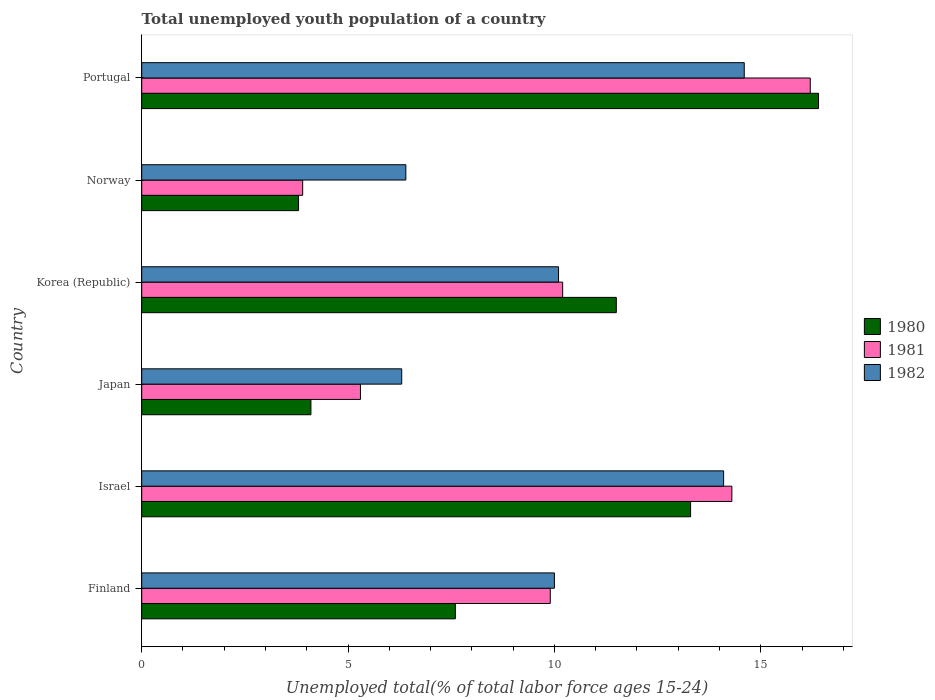How many different coloured bars are there?
Provide a succinct answer. 3. Are the number of bars per tick equal to the number of legend labels?
Your answer should be very brief. Yes. Are the number of bars on each tick of the Y-axis equal?
Keep it short and to the point. Yes. How many bars are there on the 2nd tick from the bottom?
Your answer should be compact. 3. What is the percentage of total unemployed youth population of a country in 1981 in Norway?
Your answer should be compact. 3.9. Across all countries, what is the maximum percentage of total unemployed youth population of a country in 1981?
Keep it short and to the point. 16.2. Across all countries, what is the minimum percentage of total unemployed youth population of a country in 1980?
Ensure brevity in your answer.  3.8. In which country was the percentage of total unemployed youth population of a country in 1980 maximum?
Provide a succinct answer. Portugal. In which country was the percentage of total unemployed youth population of a country in 1982 minimum?
Ensure brevity in your answer.  Japan. What is the total percentage of total unemployed youth population of a country in 1980 in the graph?
Give a very brief answer. 56.7. What is the difference between the percentage of total unemployed youth population of a country in 1980 in Finland and that in Japan?
Provide a short and direct response. 3.5. What is the difference between the percentage of total unemployed youth population of a country in 1982 in Portugal and the percentage of total unemployed youth population of a country in 1981 in Korea (Republic)?
Ensure brevity in your answer.  4.4. What is the average percentage of total unemployed youth population of a country in 1982 per country?
Provide a succinct answer. 10.25. What is the difference between the percentage of total unemployed youth population of a country in 1980 and percentage of total unemployed youth population of a country in 1982 in Portugal?
Offer a terse response. 1.8. What is the ratio of the percentage of total unemployed youth population of a country in 1982 in Israel to that in Norway?
Your answer should be compact. 2.2. What is the difference between the highest and the lowest percentage of total unemployed youth population of a country in 1981?
Offer a terse response. 12.3. In how many countries, is the percentage of total unemployed youth population of a country in 1982 greater than the average percentage of total unemployed youth population of a country in 1982 taken over all countries?
Offer a terse response. 2. What does the 1st bar from the top in Portugal represents?
Offer a very short reply. 1982. Is it the case that in every country, the sum of the percentage of total unemployed youth population of a country in 1980 and percentage of total unemployed youth population of a country in 1981 is greater than the percentage of total unemployed youth population of a country in 1982?
Ensure brevity in your answer.  Yes. How many bars are there?
Provide a succinct answer. 18. How many countries are there in the graph?
Your response must be concise. 6. Are the values on the major ticks of X-axis written in scientific E-notation?
Provide a short and direct response. No. Does the graph contain any zero values?
Offer a very short reply. No. Where does the legend appear in the graph?
Give a very brief answer. Center right. What is the title of the graph?
Provide a short and direct response. Total unemployed youth population of a country. Does "2013" appear as one of the legend labels in the graph?
Your answer should be compact. No. What is the label or title of the X-axis?
Keep it short and to the point. Unemployed total(% of total labor force ages 15-24). What is the label or title of the Y-axis?
Your answer should be very brief. Country. What is the Unemployed total(% of total labor force ages 15-24) in 1980 in Finland?
Ensure brevity in your answer.  7.6. What is the Unemployed total(% of total labor force ages 15-24) in 1981 in Finland?
Your answer should be very brief. 9.9. What is the Unemployed total(% of total labor force ages 15-24) of 1982 in Finland?
Ensure brevity in your answer.  10. What is the Unemployed total(% of total labor force ages 15-24) of 1980 in Israel?
Your response must be concise. 13.3. What is the Unemployed total(% of total labor force ages 15-24) of 1981 in Israel?
Your response must be concise. 14.3. What is the Unemployed total(% of total labor force ages 15-24) of 1982 in Israel?
Provide a short and direct response. 14.1. What is the Unemployed total(% of total labor force ages 15-24) in 1980 in Japan?
Ensure brevity in your answer.  4.1. What is the Unemployed total(% of total labor force ages 15-24) in 1981 in Japan?
Keep it short and to the point. 5.3. What is the Unemployed total(% of total labor force ages 15-24) in 1982 in Japan?
Make the answer very short. 6.3. What is the Unemployed total(% of total labor force ages 15-24) in 1981 in Korea (Republic)?
Keep it short and to the point. 10.2. What is the Unemployed total(% of total labor force ages 15-24) of 1982 in Korea (Republic)?
Offer a very short reply. 10.1. What is the Unemployed total(% of total labor force ages 15-24) of 1980 in Norway?
Offer a very short reply. 3.8. What is the Unemployed total(% of total labor force ages 15-24) in 1981 in Norway?
Provide a short and direct response. 3.9. What is the Unemployed total(% of total labor force ages 15-24) of 1982 in Norway?
Your answer should be compact. 6.4. What is the Unemployed total(% of total labor force ages 15-24) in 1980 in Portugal?
Keep it short and to the point. 16.4. What is the Unemployed total(% of total labor force ages 15-24) in 1981 in Portugal?
Keep it short and to the point. 16.2. What is the Unemployed total(% of total labor force ages 15-24) in 1982 in Portugal?
Offer a terse response. 14.6. Across all countries, what is the maximum Unemployed total(% of total labor force ages 15-24) in 1980?
Keep it short and to the point. 16.4. Across all countries, what is the maximum Unemployed total(% of total labor force ages 15-24) of 1981?
Your answer should be compact. 16.2. Across all countries, what is the maximum Unemployed total(% of total labor force ages 15-24) of 1982?
Keep it short and to the point. 14.6. Across all countries, what is the minimum Unemployed total(% of total labor force ages 15-24) in 1980?
Offer a very short reply. 3.8. Across all countries, what is the minimum Unemployed total(% of total labor force ages 15-24) of 1981?
Your answer should be compact. 3.9. Across all countries, what is the minimum Unemployed total(% of total labor force ages 15-24) of 1982?
Provide a succinct answer. 6.3. What is the total Unemployed total(% of total labor force ages 15-24) in 1980 in the graph?
Provide a succinct answer. 56.7. What is the total Unemployed total(% of total labor force ages 15-24) of 1981 in the graph?
Give a very brief answer. 59.8. What is the total Unemployed total(% of total labor force ages 15-24) of 1982 in the graph?
Make the answer very short. 61.5. What is the difference between the Unemployed total(% of total labor force ages 15-24) in 1981 in Finland and that in Israel?
Ensure brevity in your answer.  -4.4. What is the difference between the Unemployed total(% of total labor force ages 15-24) in 1982 in Finland and that in Israel?
Provide a succinct answer. -4.1. What is the difference between the Unemployed total(% of total labor force ages 15-24) in 1980 in Finland and that in Korea (Republic)?
Give a very brief answer. -3.9. What is the difference between the Unemployed total(% of total labor force ages 15-24) in 1981 in Finland and that in Korea (Republic)?
Give a very brief answer. -0.3. What is the difference between the Unemployed total(% of total labor force ages 15-24) of 1982 in Finland and that in Korea (Republic)?
Your answer should be compact. -0.1. What is the difference between the Unemployed total(% of total labor force ages 15-24) of 1980 in Finland and that in Portugal?
Ensure brevity in your answer.  -8.8. What is the difference between the Unemployed total(% of total labor force ages 15-24) in 1982 in Finland and that in Portugal?
Your answer should be very brief. -4.6. What is the difference between the Unemployed total(% of total labor force ages 15-24) of 1980 in Israel and that in Japan?
Ensure brevity in your answer.  9.2. What is the difference between the Unemployed total(% of total labor force ages 15-24) of 1981 in Israel and that in Japan?
Give a very brief answer. 9. What is the difference between the Unemployed total(% of total labor force ages 15-24) of 1982 in Israel and that in Japan?
Ensure brevity in your answer.  7.8. What is the difference between the Unemployed total(% of total labor force ages 15-24) in 1980 in Israel and that in Korea (Republic)?
Keep it short and to the point. 1.8. What is the difference between the Unemployed total(% of total labor force ages 15-24) in 1981 in Israel and that in Korea (Republic)?
Provide a short and direct response. 4.1. What is the difference between the Unemployed total(% of total labor force ages 15-24) in 1980 in Israel and that in Norway?
Your answer should be compact. 9.5. What is the difference between the Unemployed total(% of total labor force ages 15-24) in 1981 in Israel and that in Norway?
Your answer should be compact. 10.4. What is the difference between the Unemployed total(% of total labor force ages 15-24) of 1982 in Israel and that in Norway?
Offer a very short reply. 7.7. What is the difference between the Unemployed total(% of total labor force ages 15-24) of 1980 in Israel and that in Portugal?
Provide a short and direct response. -3.1. What is the difference between the Unemployed total(% of total labor force ages 15-24) in 1981 in Israel and that in Portugal?
Offer a very short reply. -1.9. What is the difference between the Unemployed total(% of total labor force ages 15-24) in 1982 in Israel and that in Portugal?
Your answer should be compact. -0.5. What is the difference between the Unemployed total(% of total labor force ages 15-24) of 1980 in Japan and that in Korea (Republic)?
Your answer should be compact. -7.4. What is the difference between the Unemployed total(% of total labor force ages 15-24) of 1981 in Japan and that in Korea (Republic)?
Keep it short and to the point. -4.9. What is the difference between the Unemployed total(% of total labor force ages 15-24) of 1980 in Japan and that in Norway?
Make the answer very short. 0.3. What is the difference between the Unemployed total(% of total labor force ages 15-24) of 1981 in Korea (Republic) and that in Norway?
Provide a succinct answer. 6.3. What is the difference between the Unemployed total(% of total labor force ages 15-24) of 1982 in Korea (Republic) and that in Norway?
Ensure brevity in your answer.  3.7. What is the difference between the Unemployed total(% of total labor force ages 15-24) in 1982 in Korea (Republic) and that in Portugal?
Provide a succinct answer. -4.5. What is the difference between the Unemployed total(% of total labor force ages 15-24) in 1982 in Norway and that in Portugal?
Make the answer very short. -8.2. What is the difference between the Unemployed total(% of total labor force ages 15-24) in 1980 in Finland and the Unemployed total(% of total labor force ages 15-24) in 1981 in Japan?
Keep it short and to the point. 2.3. What is the difference between the Unemployed total(% of total labor force ages 15-24) of 1980 in Finland and the Unemployed total(% of total labor force ages 15-24) of 1981 in Korea (Republic)?
Offer a very short reply. -2.6. What is the difference between the Unemployed total(% of total labor force ages 15-24) of 1981 in Finland and the Unemployed total(% of total labor force ages 15-24) of 1982 in Korea (Republic)?
Ensure brevity in your answer.  -0.2. What is the difference between the Unemployed total(% of total labor force ages 15-24) of 1980 in Finland and the Unemployed total(% of total labor force ages 15-24) of 1981 in Norway?
Make the answer very short. 3.7. What is the difference between the Unemployed total(% of total labor force ages 15-24) of 1980 in Finland and the Unemployed total(% of total labor force ages 15-24) of 1982 in Norway?
Keep it short and to the point. 1.2. What is the difference between the Unemployed total(% of total labor force ages 15-24) in 1980 in Finland and the Unemployed total(% of total labor force ages 15-24) in 1982 in Portugal?
Provide a succinct answer. -7. What is the difference between the Unemployed total(% of total labor force ages 15-24) in 1981 in Finland and the Unemployed total(% of total labor force ages 15-24) in 1982 in Portugal?
Ensure brevity in your answer.  -4.7. What is the difference between the Unemployed total(% of total labor force ages 15-24) of 1980 in Israel and the Unemployed total(% of total labor force ages 15-24) of 1981 in Japan?
Provide a succinct answer. 8. What is the difference between the Unemployed total(% of total labor force ages 15-24) in 1980 in Israel and the Unemployed total(% of total labor force ages 15-24) in 1982 in Korea (Republic)?
Give a very brief answer. 3.2. What is the difference between the Unemployed total(% of total labor force ages 15-24) of 1981 in Israel and the Unemployed total(% of total labor force ages 15-24) of 1982 in Korea (Republic)?
Make the answer very short. 4.2. What is the difference between the Unemployed total(% of total labor force ages 15-24) of 1981 in Israel and the Unemployed total(% of total labor force ages 15-24) of 1982 in Portugal?
Give a very brief answer. -0.3. What is the difference between the Unemployed total(% of total labor force ages 15-24) in 1980 in Japan and the Unemployed total(% of total labor force ages 15-24) in 1981 in Korea (Republic)?
Your answer should be very brief. -6.1. What is the difference between the Unemployed total(% of total labor force ages 15-24) of 1980 in Japan and the Unemployed total(% of total labor force ages 15-24) of 1982 in Korea (Republic)?
Your answer should be very brief. -6. What is the difference between the Unemployed total(% of total labor force ages 15-24) in 1980 in Japan and the Unemployed total(% of total labor force ages 15-24) in 1982 in Norway?
Keep it short and to the point. -2.3. What is the difference between the Unemployed total(% of total labor force ages 15-24) of 1981 in Japan and the Unemployed total(% of total labor force ages 15-24) of 1982 in Norway?
Your answer should be compact. -1.1. What is the difference between the Unemployed total(% of total labor force ages 15-24) in 1980 in Japan and the Unemployed total(% of total labor force ages 15-24) in 1981 in Portugal?
Provide a short and direct response. -12.1. What is the difference between the Unemployed total(% of total labor force ages 15-24) in 1980 in Japan and the Unemployed total(% of total labor force ages 15-24) in 1982 in Portugal?
Your answer should be compact. -10.5. What is the difference between the Unemployed total(% of total labor force ages 15-24) in 1980 in Korea (Republic) and the Unemployed total(% of total labor force ages 15-24) in 1981 in Norway?
Your answer should be very brief. 7.6. What is the difference between the Unemployed total(% of total labor force ages 15-24) in 1981 in Korea (Republic) and the Unemployed total(% of total labor force ages 15-24) in 1982 in Norway?
Your answer should be compact. 3.8. What is the difference between the Unemployed total(% of total labor force ages 15-24) in 1980 in Korea (Republic) and the Unemployed total(% of total labor force ages 15-24) in 1981 in Portugal?
Ensure brevity in your answer.  -4.7. What is the difference between the Unemployed total(% of total labor force ages 15-24) in 1981 in Korea (Republic) and the Unemployed total(% of total labor force ages 15-24) in 1982 in Portugal?
Your answer should be very brief. -4.4. What is the average Unemployed total(% of total labor force ages 15-24) in 1980 per country?
Your response must be concise. 9.45. What is the average Unemployed total(% of total labor force ages 15-24) in 1981 per country?
Give a very brief answer. 9.97. What is the average Unemployed total(% of total labor force ages 15-24) in 1982 per country?
Ensure brevity in your answer.  10.25. What is the difference between the Unemployed total(% of total labor force ages 15-24) in 1980 and Unemployed total(% of total labor force ages 15-24) in 1982 in Finland?
Offer a very short reply. -2.4. What is the difference between the Unemployed total(% of total labor force ages 15-24) in 1980 and Unemployed total(% of total labor force ages 15-24) in 1982 in Israel?
Provide a short and direct response. -0.8. What is the difference between the Unemployed total(% of total labor force ages 15-24) of 1981 and Unemployed total(% of total labor force ages 15-24) of 1982 in Israel?
Give a very brief answer. 0.2. What is the difference between the Unemployed total(% of total labor force ages 15-24) in 1980 and Unemployed total(% of total labor force ages 15-24) in 1981 in Japan?
Offer a terse response. -1.2. What is the difference between the Unemployed total(% of total labor force ages 15-24) in 1980 and Unemployed total(% of total labor force ages 15-24) in 1982 in Japan?
Provide a succinct answer. -2.2. What is the difference between the Unemployed total(% of total labor force ages 15-24) in 1980 and Unemployed total(% of total labor force ages 15-24) in 1981 in Korea (Republic)?
Offer a very short reply. 1.3. What is the difference between the Unemployed total(% of total labor force ages 15-24) in 1981 and Unemployed total(% of total labor force ages 15-24) in 1982 in Korea (Republic)?
Provide a succinct answer. 0.1. What is the difference between the Unemployed total(% of total labor force ages 15-24) of 1980 and Unemployed total(% of total labor force ages 15-24) of 1981 in Norway?
Make the answer very short. -0.1. What is the difference between the Unemployed total(% of total labor force ages 15-24) of 1981 and Unemployed total(% of total labor force ages 15-24) of 1982 in Norway?
Offer a terse response. -2.5. What is the difference between the Unemployed total(% of total labor force ages 15-24) in 1980 and Unemployed total(% of total labor force ages 15-24) in 1981 in Portugal?
Offer a terse response. 0.2. What is the difference between the Unemployed total(% of total labor force ages 15-24) of 1981 and Unemployed total(% of total labor force ages 15-24) of 1982 in Portugal?
Your answer should be very brief. 1.6. What is the ratio of the Unemployed total(% of total labor force ages 15-24) of 1981 in Finland to that in Israel?
Ensure brevity in your answer.  0.69. What is the ratio of the Unemployed total(% of total labor force ages 15-24) in 1982 in Finland to that in Israel?
Ensure brevity in your answer.  0.71. What is the ratio of the Unemployed total(% of total labor force ages 15-24) in 1980 in Finland to that in Japan?
Your answer should be compact. 1.85. What is the ratio of the Unemployed total(% of total labor force ages 15-24) in 1981 in Finland to that in Japan?
Your response must be concise. 1.87. What is the ratio of the Unemployed total(% of total labor force ages 15-24) of 1982 in Finland to that in Japan?
Offer a very short reply. 1.59. What is the ratio of the Unemployed total(% of total labor force ages 15-24) in 1980 in Finland to that in Korea (Republic)?
Provide a short and direct response. 0.66. What is the ratio of the Unemployed total(% of total labor force ages 15-24) of 1981 in Finland to that in Korea (Republic)?
Your response must be concise. 0.97. What is the ratio of the Unemployed total(% of total labor force ages 15-24) of 1980 in Finland to that in Norway?
Your response must be concise. 2. What is the ratio of the Unemployed total(% of total labor force ages 15-24) in 1981 in Finland to that in Norway?
Offer a terse response. 2.54. What is the ratio of the Unemployed total(% of total labor force ages 15-24) in 1982 in Finland to that in Norway?
Your response must be concise. 1.56. What is the ratio of the Unemployed total(% of total labor force ages 15-24) of 1980 in Finland to that in Portugal?
Your response must be concise. 0.46. What is the ratio of the Unemployed total(% of total labor force ages 15-24) in 1981 in Finland to that in Portugal?
Make the answer very short. 0.61. What is the ratio of the Unemployed total(% of total labor force ages 15-24) in 1982 in Finland to that in Portugal?
Offer a very short reply. 0.68. What is the ratio of the Unemployed total(% of total labor force ages 15-24) in 1980 in Israel to that in Japan?
Your answer should be compact. 3.24. What is the ratio of the Unemployed total(% of total labor force ages 15-24) of 1981 in Israel to that in Japan?
Your response must be concise. 2.7. What is the ratio of the Unemployed total(% of total labor force ages 15-24) of 1982 in Israel to that in Japan?
Ensure brevity in your answer.  2.24. What is the ratio of the Unemployed total(% of total labor force ages 15-24) of 1980 in Israel to that in Korea (Republic)?
Your answer should be very brief. 1.16. What is the ratio of the Unemployed total(% of total labor force ages 15-24) of 1981 in Israel to that in Korea (Republic)?
Your answer should be very brief. 1.4. What is the ratio of the Unemployed total(% of total labor force ages 15-24) of 1982 in Israel to that in Korea (Republic)?
Offer a very short reply. 1.4. What is the ratio of the Unemployed total(% of total labor force ages 15-24) in 1980 in Israel to that in Norway?
Your answer should be compact. 3.5. What is the ratio of the Unemployed total(% of total labor force ages 15-24) in 1981 in Israel to that in Norway?
Offer a very short reply. 3.67. What is the ratio of the Unemployed total(% of total labor force ages 15-24) in 1982 in Israel to that in Norway?
Keep it short and to the point. 2.2. What is the ratio of the Unemployed total(% of total labor force ages 15-24) of 1980 in Israel to that in Portugal?
Offer a very short reply. 0.81. What is the ratio of the Unemployed total(% of total labor force ages 15-24) of 1981 in Israel to that in Portugal?
Provide a short and direct response. 0.88. What is the ratio of the Unemployed total(% of total labor force ages 15-24) of 1982 in Israel to that in Portugal?
Give a very brief answer. 0.97. What is the ratio of the Unemployed total(% of total labor force ages 15-24) in 1980 in Japan to that in Korea (Republic)?
Your response must be concise. 0.36. What is the ratio of the Unemployed total(% of total labor force ages 15-24) in 1981 in Japan to that in Korea (Republic)?
Provide a short and direct response. 0.52. What is the ratio of the Unemployed total(% of total labor force ages 15-24) of 1982 in Japan to that in Korea (Republic)?
Offer a very short reply. 0.62. What is the ratio of the Unemployed total(% of total labor force ages 15-24) in 1980 in Japan to that in Norway?
Offer a terse response. 1.08. What is the ratio of the Unemployed total(% of total labor force ages 15-24) in 1981 in Japan to that in Norway?
Provide a short and direct response. 1.36. What is the ratio of the Unemployed total(% of total labor force ages 15-24) of 1982 in Japan to that in Norway?
Your answer should be compact. 0.98. What is the ratio of the Unemployed total(% of total labor force ages 15-24) in 1981 in Japan to that in Portugal?
Offer a very short reply. 0.33. What is the ratio of the Unemployed total(% of total labor force ages 15-24) in 1982 in Japan to that in Portugal?
Your answer should be compact. 0.43. What is the ratio of the Unemployed total(% of total labor force ages 15-24) in 1980 in Korea (Republic) to that in Norway?
Keep it short and to the point. 3.03. What is the ratio of the Unemployed total(% of total labor force ages 15-24) in 1981 in Korea (Republic) to that in Norway?
Give a very brief answer. 2.62. What is the ratio of the Unemployed total(% of total labor force ages 15-24) of 1982 in Korea (Republic) to that in Norway?
Your answer should be very brief. 1.58. What is the ratio of the Unemployed total(% of total labor force ages 15-24) of 1980 in Korea (Republic) to that in Portugal?
Provide a succinct answer. 0.7. What is the ratio of the Unemployed total(% of total labor force ages 15-24) of 1981 in Korea (Republic) to that in Portugal?
Offer a terse response. 0.63. What is the ratio of the Unemployed total(% of total labor force ages 15-24) in 1982 in Korea (Republic) to that in Portugal?
Provide a short and direct response. 0.69. What is the ratio of the Unemployed total(% of total labor force ages 15-24) of 1980 in Norway to that in Portugal?
Make the answer very short. 0.23. What is the ratio of the Unemployed total(% of total labor force ages 15-24) in 1981 in Norway to that in Portugal?
Offer a very short reply. 0.24. What is the ratio of the Unemployed total(% of total labor force ages 15-24) of 1982 in Norway to that in Portugal?
Make the answer very short. 0.44. What is the difference between the highest and the second highest Unemployed total(% of total labor force ages 15-24) of 1981?
Ensure brevity in your answer.  1.9. What is the difference between the highest and the second highest Unemployed total(% of total labor force ages 15-24) in 1982?
Offer a terse response. 0.5. 